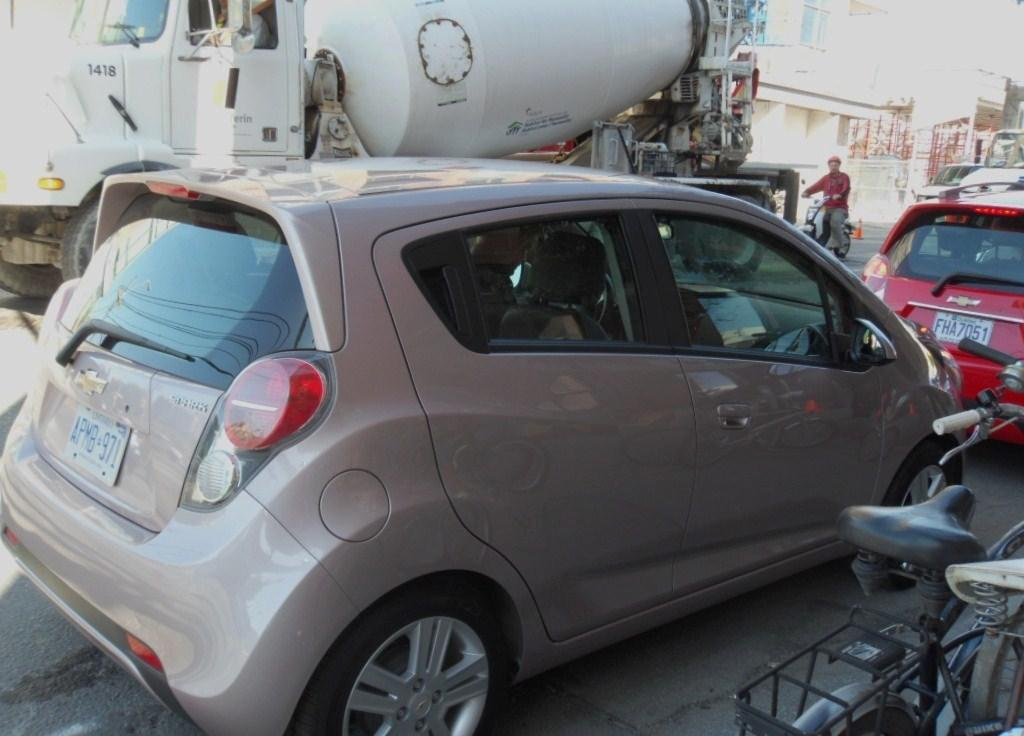What types of vehicles are in the image? There are vehicles in the image, but the specific types are not mentioned. Can you describe the color of one of the vehicles? One vehicle is gray in color. What activity is happening in the background of the image? There is a person riding a bike in the background. What can be seen in the distance behind the vehicles? There are buildings and trees with green color visible in the background. Is there any quicksand visible in the image? No, there is no quicksand present in the image. What type of lock is used to secure the vehicles in the image? There is no information about locks or security measures for the vehicles in the image. 